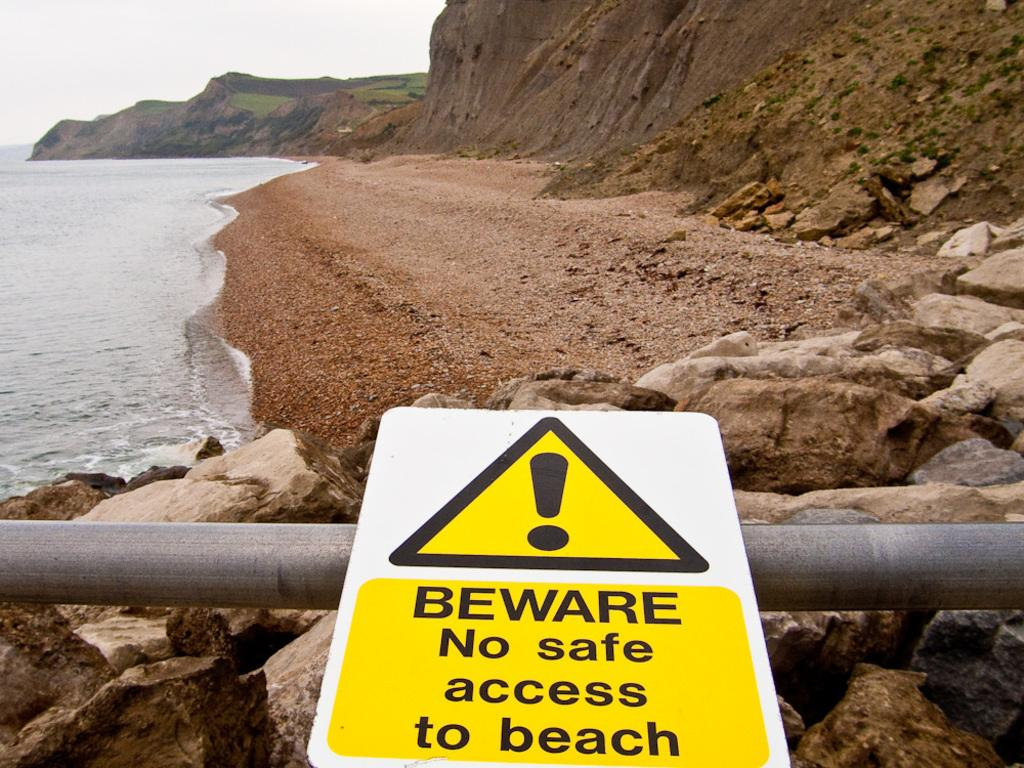What is on the sign board that is visible in the image? There is a sign board with text in the image. What is the rod used for in the image? The rod is on the surface of the rocks in the image, but its purpose is not specified. What can be seen in the background of the image? There is a river and the sky visible in the background of the image. Can you see a pig supporting the rod in the image? There is no pig present in the image, and the rod's purpose is not specified, so it cannot be determined if a pig is supporting it. What type of cast is visible on the rocks in the image? There is no cast present on the rocks in the image. 